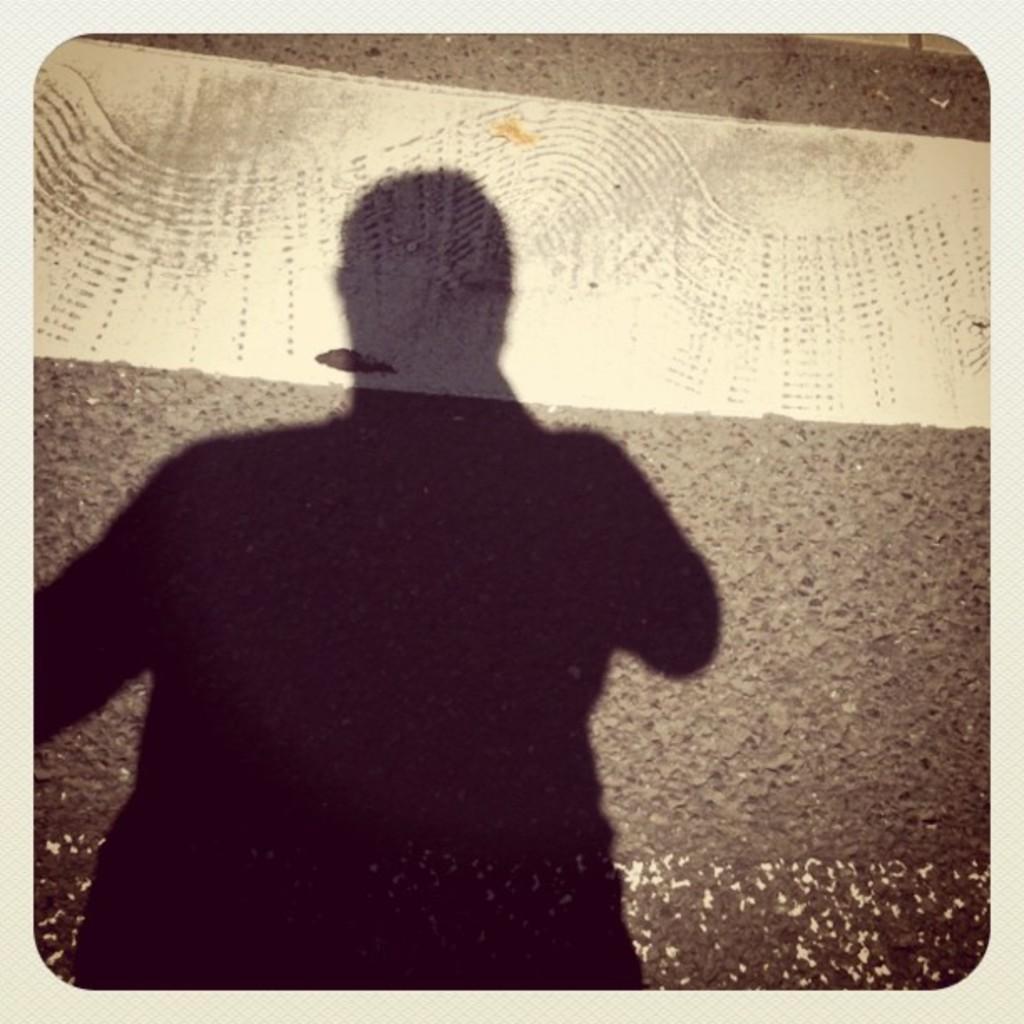Could you give a brief overview of what you see in this image? On the left side of the image we can see a person shadow is present. In the background of the image road is there. 